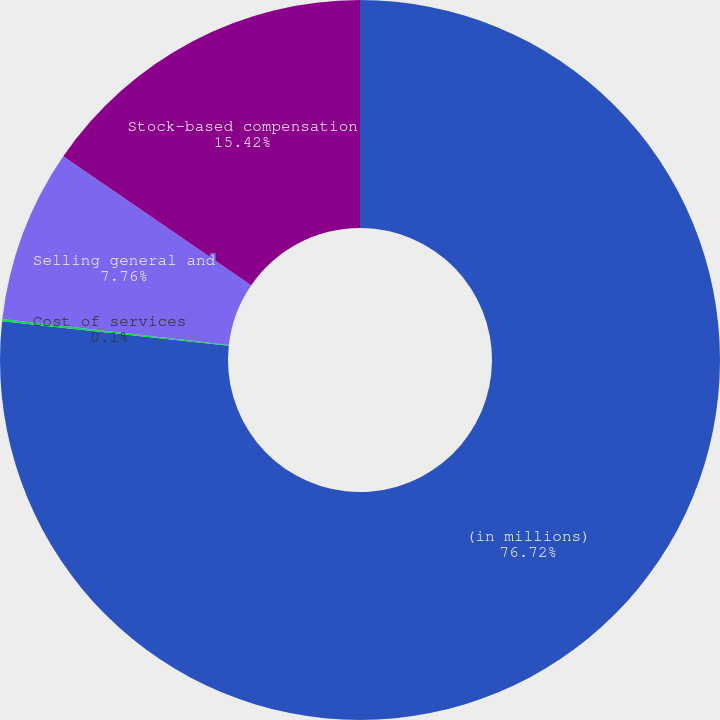<chart> <loc_0><loc_0><loc_500><loc_500><pie_chart><fcel>(in millions)<fcel>Cost of services<fcel>Selling general and<fcel>Stock-based compensation<nl><fcel>76.72%<fcel>0.1%<fcel>7.76%<fcel>15.42%<nl></chart> 